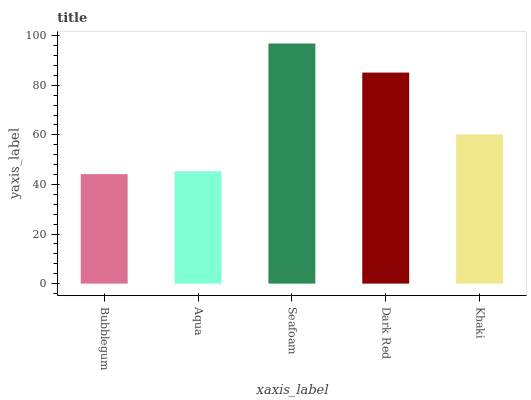Is Bubblegum the minimum?
Answer yes or no. Yes. Is Seafoam the maximum?
Answer yes or no. Yes. Is Aqua the minimum?
Answer yes or no. No. Is Aqua the maximum?
Answer yes or no. No. Is Aqua greater than Bubblegum?
Answer yes or no. Yes. Is Bubblegum less than Aqua?
Answer yes or no. Yes. Is Bubblegum greater than Aqua?
Answer yes or no. No. Is Aqua less than Bubblegum?
Answer yes or no. No. Is Khaki the high median?
Answer yes or no. Yes. Is Khaki the low median?
Answer yes or no. Yes. Is Bubblegum the high median?
Answer yes or no. No. Is Bubblegum the low median?
Answer yes or no. No. 